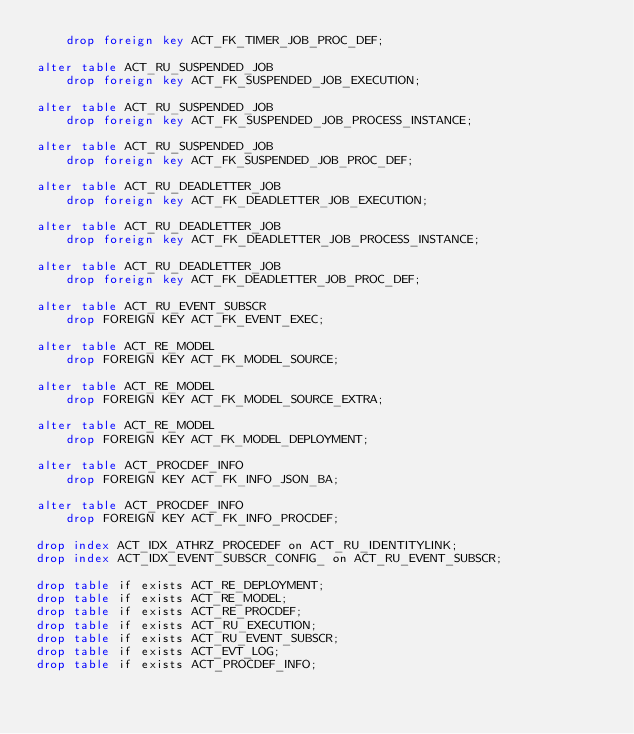Convert code to text. <code><loc_0><loc_0><loc_500><loc_500><_SQL_>    drop foreign key ACT_FK_TIMER_JOB_PROC_DEF;
    
alter table ACT_RU_SUSPENDED_JOB 
    drop foreign key ACT_FK_SUSPENDED_JOB_EXECUTION;
    
alter table ACT_RU_SUSPENDED_JOB 
    drop foreign key ACT_FK_SUSPENDED_JOB_PROCESS_INSTANCE;
    
alter table ACT_RU_SUSPENDED_JOB 
    drop foreign key ACT_FK_SUSPENDED_JOB_PROC_DEF;
    
alter table ACT_RU_DEADLETTER_JOB 
    drop foreign key ACT_FK_DEADLETTER_JOB_EXECUTION;
    
alter table ACT_RU_DEADLETTER_JOB 
    drop foreign key ACT_FK_DEADLETTER_JOB_PROCESS_INSTANCE;
    
alter table ACT_RU_DEADLETTER_JOB 
    drop foreign key ACT_FK_DEADLETTER_JOB_PROC_DEF;
    
alter table ACT_RU_EVENT_SUBSCR
    drop FOREIGN KEY ACT_FK_EVENT_EXEC;

alter table ACT_RE_MODEL 
    drop FOREIGN KEY ACT_FK_MODEL_SOURCE;

alter table ACT_RE_MODEL 
    drop FOREIGN KEY ACT_FK_MODEL_SOURCE_EXTRA;
    
alter table ACT_RE_MODEL 
    drop FOREIGN KEY ACT_FK_MODEL_DEPLOYMENT;

alter table ACT_PROCDEF_INFO 
    drop FOREIGN KEY ACT_FK_INFO_JSON_BA;
    
alter table ACT_PROCDEF_INFO 
    drop FOREIGN KEY ACT_FK_INFO_PROCDEF;
    
drop index ACT_IDX_ATHRZ_PROCEDEF on ACT_RU_IDENTITYLINK;
drop index ACT_IDX_EVENT_SUBSCR_CONFIG_ on ACT_RU_EVENT_SUBSCR;
    
drop table if exists ACT_RE_DEPLOYMENT;
drop table if exists ACT_RE_MODEL;
drop table if exists ACT_RE_PROCDEF;
drop table if exists ACT_RU_EXECUTION;
drop table if exists ACT_RU_EVENT_SUBSCR;
drop table if exists ACT_EVT_LOG;
drop table if exists ACT_PROCDEF_INFO;</code> 